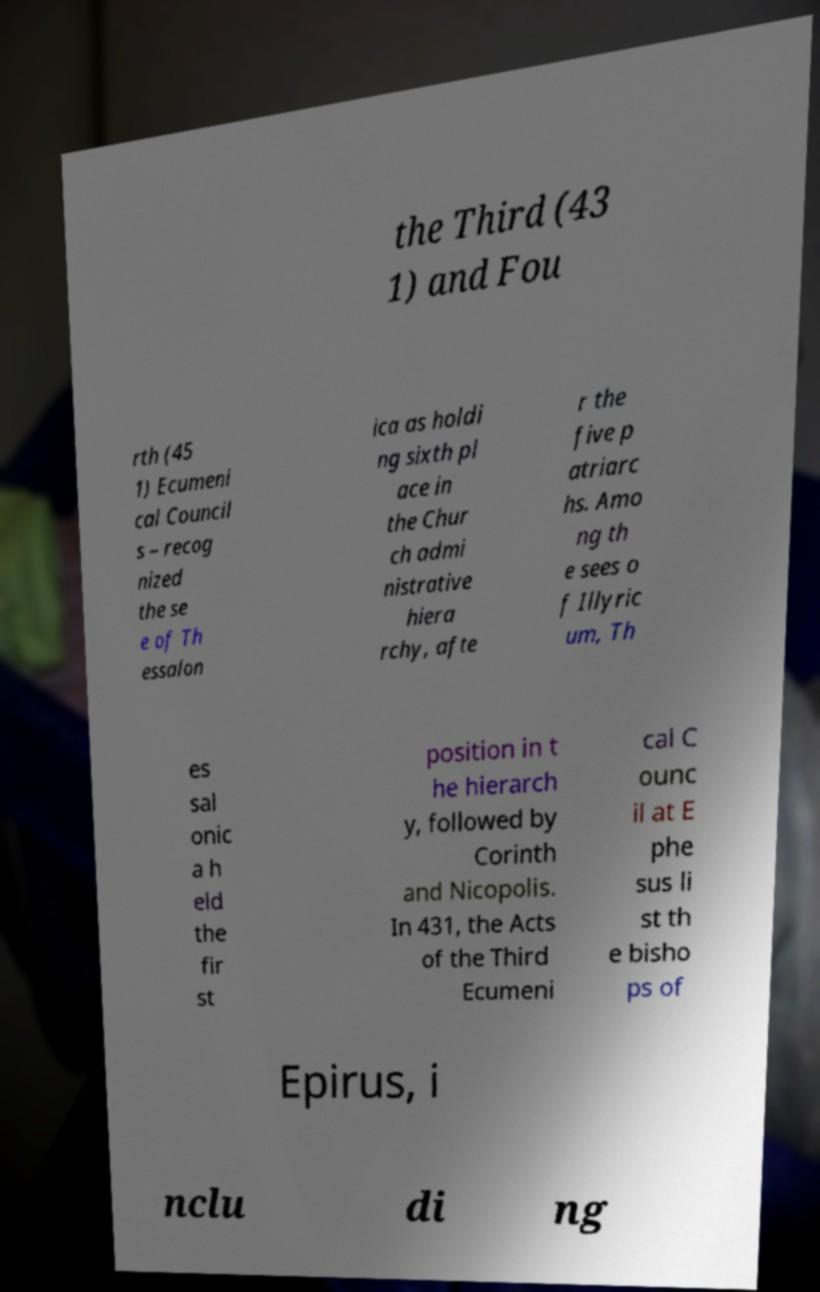Please identify and transcribe the text found in this image. the Third (43 1) and Fou rth (45 1) Ecumeni cal Council s – recog nized the se e of Th essalon ica as holdi ng sixth pl ace in the Chur ch admi nistrative hiera rchy, afte r the five p atriarc hs. Amo ng th e sees o f Illyric um, Th es sal onic a h eld the fir st position in t he hierarch y, followed by Corinth and Nicopolis. In 431, the Acts of the Third Ecumeni cal C ounc il at E phe sus li st th e bisho ps of Epirus, i nclu di ng 